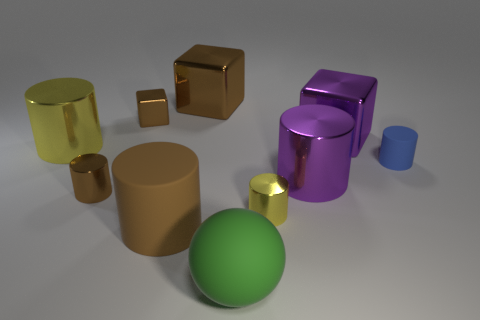What number of other objects are there of the same color as the big matte sphere?
Provide a succinct answer. 0. Does the rubber cylinder that is on the right side of the purple metal cube have the same size as the big brown cube?
Keep it short and to the point. No. Is the small metal cube the same color as the large rubber cylinder?
Make the answer very short. Yes. There is a tiny shiny object that is behind the yellow metal cylinder to the left of the brown object that is right of the brown rubber cylinder; what color is it?
Offer a very short reply. Brown. How many objects are small objects that are behind the tiny yellow thing or tiny cyan metal things?
Your response must be concise. 3. What material is the brown cylinder that is the same size as the green rubber sphere?
Your answer should be very brief. Rubber. What material is the green sphere in front of the yellow cylinder in front of the big metallic thing left of the tiny brown cylinder made of?
Offer a very short reply. Rubber. The tiny metallic cube is what color?
Your response must be concise. Brown. What number of large things are either brown things or spheres?
Offer a very short reply. 3. There is a tiny thing that is the same color as the small metallic cube; what material is it?
Keep it short and to the point. Metal. 